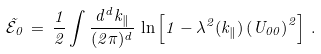Convert formula to latex. <formula><loc_0><loc_0><loc_500><loc_500>\tilde { \mathcal { E } } _ { 0 } \, = \, \frac { 1 } { 2 } \int \frac { d ^ { d } k _ { \| } } { ( 2 \pi ) ^ { d } } \, \ln \left [ 1 - \lambda ^ { 2 } ( k _ { \| } ) \left ( U _ { 0 0 } \right ) ^ { 2 } \right ] \, .</formula> 